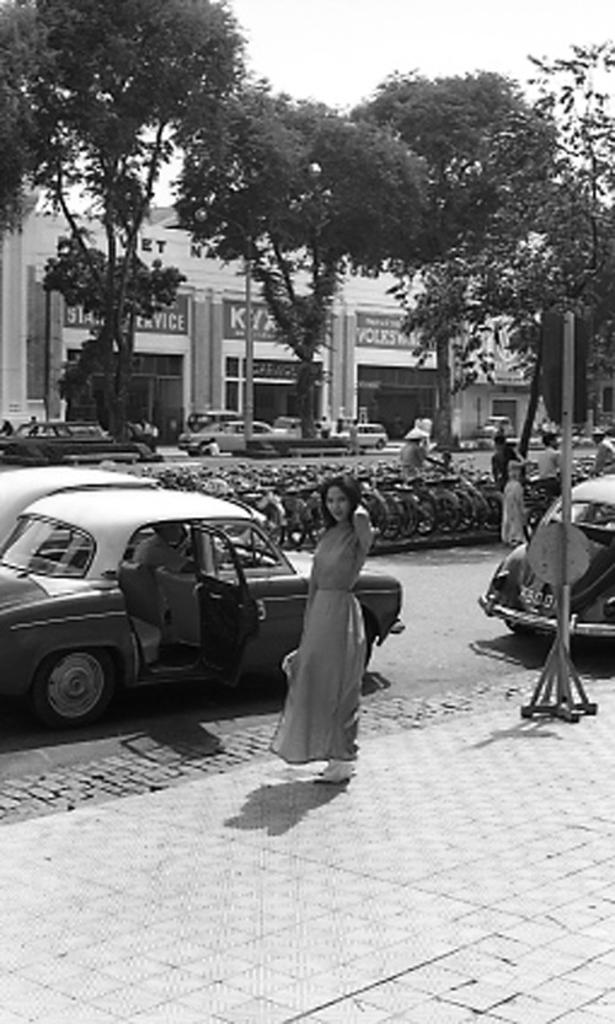What types of vehicles can be seen in the image? There are parked cars in the image. What other mode of transportation is present in the image? There are parked bicycles in the image. What natural elements can be seen in the image? There are trees in the image. Who is present in the image? There is a woman standing in the image. What type of structure is visible in the image? There is a building in the image. How many teeth can be seen on the bicycles in the image? There are no teeth present on the bicycles in the image. What type of cable is used to connect the trees in the image? There is no cable connecting the trees in the image. 